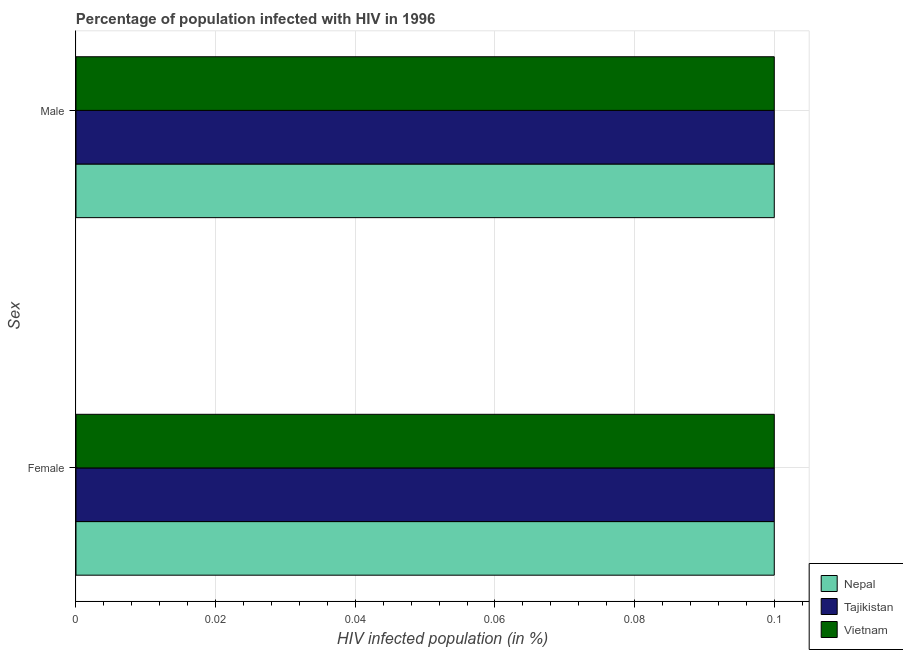How many different coloured bars are there?
Your answer should be compact. 3. How many groups of bars are there?
Your answer should be very brief. 2. How many bars are there on the 2nd tick from the top?
Ensure brevity in your answer.  3. What is the label of the 1st group of bars from the top?
Keep it short and to the point. Male. Across all countries, what is the minimum percentage of females who are infected with hiv?
Your answer should be very brief. 0.1. In which country was the percentage of males who are infected with hiv maximum?
Offer a terse response. Nepal. In which country was the percentage of males who are infected with hiv minimum?
Give a very brief answer. Nepal. What is the total percentage of females who are infected with hiv in the graph?
Ensure brevity in your answer.  0.3. What is the difference between the percentage of females who are infected with hiv in Vietnam and that in Nepal?
Offer a terse response. 0. What is the difference between the percentage of females who are infected with hiv in Tajikistan and the percentage of males who are infected with hiv in Nepal?
Make the answer very short. 0. What is the average percentage of females who are infected with hiv per country?
Ensure brevity in your answer.  0.1. What is the difference between the percentage of males who are infected with hiv and percentage of females who are infected with hiv in Tajikistan?
Offer a very short reply. 0. What is the ratio of the percentage of males who are infected with hiv in Tajikistan to that in Nepal?
Make the answer very short. 1. Is the percentage of males who are infected with hiv in Tajikistan less than that in Nepal?
Your response must be concise. No. What does the 1st bar from the top in Male represents?
Provide a succinct answer. Vietnam. What does the 3rd bar from the bottom in Female represents?
Offer a very short reply. Vietnam. Does the graph contain any zero values?
Provide a succinct answer. No. Where does the legend appear in the graph?
Keep it short and to the point. Bottom right. How many legend labels are there?
Offer a terse response. 3. How are the legend labels stacked?
Ensure brevity in your answer.  Vertical. What is the title of the graph?
Your answer should be very brief. Percentage of population infected with HIV in 1996. What is the label or title of the X-axis?
Keep it short and to the point. HIV infected population (in %). What is the label or title of the Y-axis?
Offer a terse response. Sex. What is the HIV infected population (in %) in Tajikistan in Female?
Offer a terse response. 0.1. What is the HIV infected population (in %) in Nepal in Male?
Ensure brevity in your answer.  0.1. What is the HIV infected population (in %) of Tajikistan in Male?
Ensure brevity in your answer.  0.1. What is the HIV infected population (in %) of Vietnam in Male?
Give a very brief answer. 0.1. Across all Sex, what is the maximum HIV infected population (in %) in Tajikistan?
Your response must be concise. 0.1. Across all Sex, what is the maximum HIV infected population (in %) in Vietnam?
Keep it short and to the point. 0.1. Across all Sex, what is the minimum HIV infected population (in %) in Tajikistan?
Provide a short and direct response. 0.1. Across all Sex, what is the minimum HIV infected population (in %) in Vietnam?
Provide a short and direct response. 0.1. What is the total HIV infected population (in %) in Nepal in the graph?
Provide a succinct answer. 0.2. What is the difference between the HIV infected population (in %) of Nepal in Female and that in Male?
Make the answer very short. 0. What is the difference between the HIV infected population (in %) in Nepal in Female and the HIV infected population (in %) in Vietnam in Male?
Keep it short and to the point. 0. What is the average HIV infected population (in %) in Tajikistan per Sex?
Offer a terse response. 0.1. What is the average HIV infected population (in %) of Vietnam per Sex?
Provide a succinct answer. 0.1. What is the difference between the HIV infected population (in %) of Nepal and HIV infected population (in %) of Tajikistan in Female?
Your response must be concise. 0. What is the difference between the HIV infected population (in %) of Nepal and HIV infected population (in %) of Vietnam in Female?
Offer a terse response. 0. What is the difference between the HIV infected population (in %) of Nepal and HIV infected population (in %) of Tajikistan in Male?
Your response must be concise. 0. What is the difference between the HIV infected population (in %) of Nepal and HIV infected population (in %) of Vietnam in Male?
Your answer should be compact. 0. What is the difference between the HIV infected population (in %) of Tajikistan and HIV infected population (in %) of Vietnam in Male?
Offer a very short reply. 0. What is the ratio of the HIV infected population (in %) of Nepal in Female to that in Male?
Your answer should be compact. 1. What is the ratio of the HIV infected population (in %) of Tajikistan in Female to that in Male?
Keep it short and to the point. 1. What is the ratio of the HIV infected population (in %) of Vietnam in Female to that in Male?
Ensure brevity in your answer.  1. What is the difference between the highest and the second highest HIV infected population (in %) of Nepal?
Your answer should be compact. 0. What is the difference between the highest and the second highest HIV infected population (in %) in Tajikistan?
Provide a succinct answer. 0. What is the difference between the highest and the lowest HIV infected population (in %) of Nepal?
Offer a terse response. 0. 